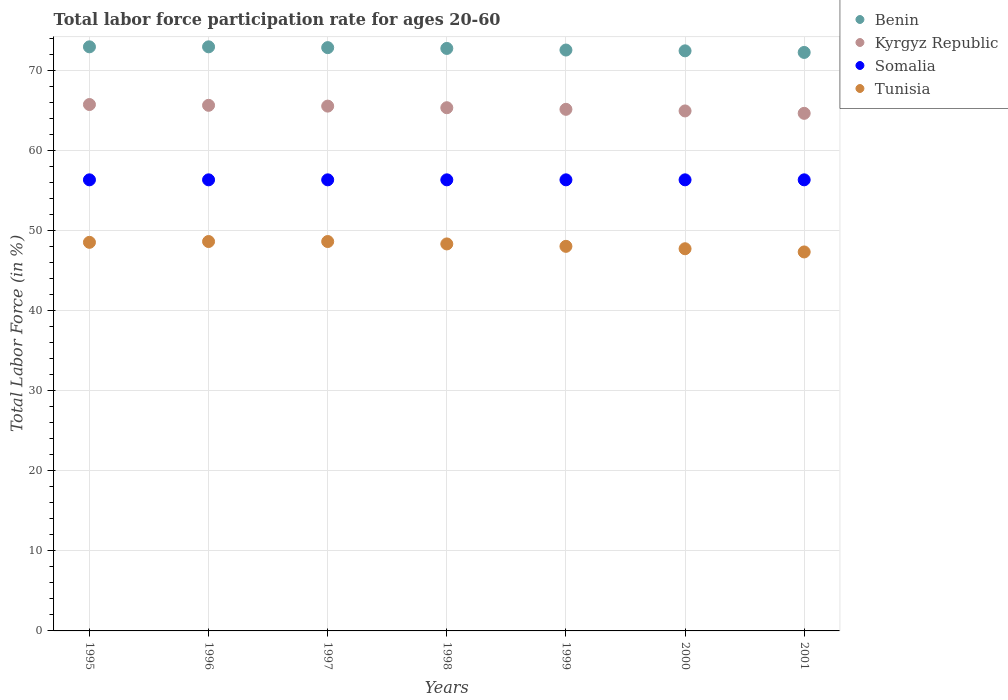What is the labor force participation rate in Somalia in 1996?
Give a very brief answer. 56.3. Across all years, what is the maximum labor force participation rate in Somalia?
Make the answer very short. 56.3. Across all years, what is the minimum labor force participation rate in Kyrgyz Republic?
Give a very brief answer. 64.6. What is the total labor force participation rate in Tunisia in the graph?
Offer a very short reply. 337. What is the difference between the labor force participation rate in Tunisia in 1995 and that in 1996?
Provide a short and direct response. -0.1. What is the difference between the labor force participation rate in Benin in 1997 and the labor force participation rate in Kyrgyz Republic in 2001?
Your answer should be compact. 8.2. What is the average labor force participation rate in Tunisia per year?
Provide a short and direct response. 48.14. In the year 1998, what is the difference between the labor force participation rate in Somalia and labor force participation rate in Kyrgyz Republic?
Provide a short and direct response. -9. What is the ratio of the labor force participation rate in Kyrgyz Republic in 1995 to that in 1996?
Your response must be concise. 1. Is the difference between the labor force participation rate in Somalia in 1996 and 1998 greater than the difference between the labor force participation rate in Kyrgyz Republic in 1996 and 1998?
Your answer should be compact. No. What is the difference between the highest and the lowest labor force participation rate in Benin?
Keep it short and to the point. 0.7. In how many years, is the labor force participation rate in Somalia greater than the average labor force participation rate in Somalia taken over all years?
Provide a short and direct response. 0. Is the labor force participation rate in Somalia strictly greater than the labor force participation rate in Tunisia over the years?
Keep it short and to the point. Yes. How many dotlines are there?
Offer a terse response. 4. How many years are there in the graph?
Ensure brevity in your answer.  7. What is the difference between two consecutive major ticks on the Y-axis?
Give a very brief answer. 10. How many legend labels are there?
Your response must be concise. 4. How are the legend labels stacked?
Your answer should be very brief. Vertical. What is the title of the graph?
Offer a terse response. Total labor force participation rate for ages 20-60. Does "Barbados" appear as one of the legend labels in the graph?
Provide a succinct answer. No. What is the label or title of the Y-axis?
Make the answer very short. Total Labor Force (in %). What is the Total Labor Force (in %) of Benin in 1995?
Offer a very short reply. 72.9. What is the Total Labor Force (in %) of Kyrgyz Republic in 1995?
Make the answer very short. 65.7. What is the Total Labor Force (in %) of Somalia in 1995?
Ensure brevity in your answer.  56.3. What is the Total Labor Force (in %) of Tunisia in 1995?
Your answer should be compact. 48.5. What is the Total Labor Force (in %) in Benin in 1996?
Provide a succinct answer. 72.9. What is the Total Labor Force (in %) of Kyrgyz Republic in 1996?
Your response must be concise. 65.6. What is the Total Labor Force (in %) of Somalia in 1996?
Keep it short and to the point. 56.3. What is the Total Labor Force (in %) of Tunisia in 1996?
Provide a short and direct response. 48.6. What is the Total Labor Force (in %) in Benin in 1997?
Your response must be concise. 72.8. What is the Total Labor Force (in %) of Kyrgyz Republic in 1997?
Give a very brief answer. 65.5. What is the Total Labor Force (in %) of Somalia in 1997?
Ensure brevity in your answer.  56.3. What is the Total Labor Force (in %) in Tunisia in 1997?
Ensure brevity in your answer.  48.6. What is the Total Labor Force (in %) in Benin in 1998?
Your response must be concise. 72.7. What is the Total Labor Force (in %) in Kyrgyz Republic in 1998?
Provide a short and direct response. 65.3. What is the Total Labor Force (in %) of Somalia in 1998?
Offer a terse response. 56.3. What is the Total Labor Force (in %) of Tunisia in 1998?
Make the answer very short. 48.3. What is the Total Labor Force (in %) of Benin in 1999?
Your answer should be compact. 72.5. What is the Total Labor Force (in %) of Kyrgyz Republic in 1999?
Make the answer very short. 65.1. What is the Total Labor Force (in %) of Somalia in 1999?
Your answer should be very brief. 56.3. What is the Total Labor Force (in %) of Benin in 2000?
Your answer should be very brief. 72.4. What is the Total Labor Force (in %) in Kyrgyz Republic in 2000?
Keep it short and to the point. 64.9. What is the Total Labor Force (in %) of Somalia in 2000?
Your response must be concise. 56.3. What is the Total Labor Force (in %) in Tunisia in 2000?
Provide a succinct answer. 47.7. What is the Total Labor Force (in %) of Benin in 2001?
Provide a short and direct response. 72.2. What is the Total Labor Force (in %) of Kyrgyz Republic in 2001?
Give a very brief answer. 64.6. What is the Total Labor Force (in %) of Somalia in 2001?
Provide a short and direct response. 56.3. What is the Total Labor Force (in %) in Tunisia in 2001?
Your response must be concise. 47.3. Across all years, what is the maximum Total Labor Force (in %) in Benin?
Provide a succinct answer. 72.9. Across all years, what is the maximum Total Labor Force (in %) of Kyrgyz Republic?
Give a very brief answer. 65.7. Across all years, what is the maximum Total Labor Force (in %) in Somalia?
Offer a terse response. 56.3. Across all years, what is the maximum Total Labor Force (in %) of Tunisia?
Provide a short and direct response. 48.6. Across all years, what is the minimum Total Labor Force (in %) of Benin?
Your answer should be compact. 72.2. Across all years, what is the minimum Total Labor Force (in %) in Kyrgyz Republic?
Make the answer very short. 64.6. Across all years, what is the minimum Total Labor Force (in %) of Somalia?
Ensure brevity in your answer.  56.3. Across all years, what is the minimum Total Labor Force (in %) of Tunisia?
Give a very brief answer. 47.3. What is the total Total Labor Force (in %) in Benin in the graph?
Make the answer very short. 508.4. What is the total Total Labor Force (in %) of Kyrgyz Republic in the graph?
Give a very brief answer. 456.7. What is the total Total Labor Force (in %) in Somalia in the graph?
Your answer should be compact. 394.1. What is the total Total Labor Force (in %) of Tunisia in the graph?
Ensure brevity in your answer.  337. What is the difference between the Total Labor Force (in %) of Kyrgyz Republic in 1995 and that in 1996?
Offer a very short reply. 0.1. What is the difference between the Total Labor Force (in %) of Tunisia in 1995 and that in 1996?
Your answer should be very brief. -0.1. What is the difference between the Total Labor Force (in %) in Kyrgyz Republic in 1995 and that in 1997?
Provide a succinct answer. 0.2. What is the difference between the Total Labor Force (in %) of Somalia in 1995 and that in 1997?
Your answer should be compact. 0. What is the difference between the Total Labor Force (in %) of Benin in 1995 and that in 1998?
Your response must be concise. 0.2. What is the difference between the Total Labor Force (in %) in Kyrgyz Republic in 1995 and that in 1998?
Provide a short and direct response. 0.4. What is the difference between the Total Labor Force (in %) in Kyrgyz Republic in 1995 and that in 1999?
Ensure brevity in your answer.  0.6. What is the difference between the Total Labor Force (in %) in Tunisia in 1995 and that in 1999?
Your response must be concise. 0.5. What is the difference between the Total Labor Force (in %) in Benin in 1995 and that in 2000?
Offer a terse response. 0.5. What is the difference between the Total Labor Force (in %) of Kyrgyz Republic in 1995 and that in 2000?
Your answer should be compact. 0.8. What is the difference between the Total Labor Force (in %) in Somalia in 1995 and that in 2001?
Provide a short and direct response. 0. What is the difference between the Total Labor Force (in %) in Tunisia in 1995 and that in 2001?
Make the answer very short. 1.2. What is the difference between the Total Labor Force (in %) of Benin in 1996 and that in 1997?
Offer a terse response. 0.1. What is the difference between the Total Labor Force (in %) in Kyrgyz Republic in 1996 and that in 1997?
Provide a short and direct response. 0.1. What is the difference between the Total Labor Force (in %) of Somalia in 1996 and that in 1997?
Offer a very short reply. 0. What is the difference between the Total Labor Force (in %) in Tunisia in 1996 and that in 1997?
Ensure brevity in your answer.  0. What is the difference between the Total Labor Force (in %) in Benin in 1996 and that in 1998?
Provide a short and direct response. 0.2. What is the difference between the Total Labor Force (in %) of Somalia in 1996 and that in 1998?
Keep it short and to the point. 0. What is the difference between the Total Labor Force (in %) in Tunisia in 1996 and that in 1998?
Ensure brevity in your answer.  0.3. What is the difference between the Total Labor Force (in %) of Benin in 1996 and that in 1999?
Your answer should be very brief. 0.4. What is the difference between the Total Labor Force (in %) in Somalia in 1996 and that in 1999?
Ensure brevity in your answer.  0. What is the difference between the Total Labor Force (in %) in Kyrgyz Republic in 1996 and that in 2000?
Keep it short and to the point. 0.7. What is the difference between the Total Labor Force (in %) of Somalia in 1996 and that in 2000?
Make the answer very short. 0. What is the difference between the Total Labor Force (in %) in Tunisia in 1996 and that in 2000?
Provide a short and direct response. 0.9. What is the difference between the Total Labor Force (in %) in Kyrgyz Republic in 1996 and that in 2001?
Give a very brief answer. 1. What is the difference between the Total Labor Force (in %) in Somalia in 1996 and that in 2001?
Your answer should be very brief. 0. What is the difference between the Total Labor Force (in %) of Kyrgyz Republic in 1997 and that in 1998?
Ensure brevity in your answer.  0.2. What is the difference between the Total Labor Force (in %) in Tunisia in 1997 and that in 1998?
Provide a succinct answer. 0.3. What is the difference between the Total Labor Force (in %) in Benin in 1997 and that in 1999?
Ensure brevity in your answer.  0.3. What is the difference between the Total Labor Force (in %) in Kyrgyz Republic in 1997 and that in 1999?
Provide a succinct answer. 0.4. What is the difference between the Total Labor Force (in %) in Somalia in 1997 and that in 1999?
Your answer should be very brief. 0. What is the difference between the Total Labor Force (in %) of Benin in 1997 and that in 2000?
Your response must be concise. 0.4. What is the difference between the Total Labor Force (in %) of Tunisia in 1997 and that in 2000?
Ensure brevity in your answer.  0.9. What is the difference between the Total Labor Force (in %) of Benin in 1997 and that in 2001?
Offer a very short reply. 0.6. What is the difference between the Total Labor Force (in %) of Tunisia in 1997 and that in 2001?
Ensure brevity in your answer.  1.3. What is the difference between the Total Labor Force (in %) in Kyrgyz Republic in 1998 and that in 1999?
Make the answer very short. 0.2. What is the difference between the Total Labor Force (in %) of Somalia in 1998 and that in 1999?
Provide a succinct answer. 0. What is the difference between the Total Labor Force (in %) of Tunisia in 1998 and that in 1999?
Your answer should be compact. 0.3. What is the difference between the Total Labor Force (in %) of Kyrgyz Republic in 1998 and that in 2000?
Provide a short and direct response. 0.4. What is the difference between the Total Labor Force (in %) of Somalia in 1998 and that in 2000?
Your answer should be very brief. 0. What is the difference between the Total Labor Force (in %) of Benin in 1998 and that in 2001?
Your response must be concise. 0.5. What is the difference between the Total Labor Force (in %) in Somalia in 1998 and that in 2001?
Offer a very short reply. 0. What is the difference between the Total Labor Force (in %) in Somalia in 1999 and that in 2000?
Keep it short and to the point. 0. What is the difference between the Total Labor Force (in %) in Benin in 1999 and that in 2001?
Your answer should be very brief. 0.3. What is the difference between the Total Labor Force (in %) in Tunisia in 1999 and that in 2001?
Offer a very short reply. 0.7. What is the difference between the Total Labor Force (in %) in Tunisia in 2000 and that in 2001?
Keep it short and to the point. 0.4. What is the difference between the Total Labor Force (in %) in Benin in 1995 and the Total Labor Force (in %) in Kyrgyz Republic in 1996?
Your response must be concise. 7.3. What is the difference between the Total Labor Force (in %) of Benin in 1995 and the Total Labor Force (in %) of Tunisia in 1996?
Provide a succinct answer. 24.3. What is the difference between the Total Labor Force (in %) in Kyrgyz Republic in 1995 and the Total Labor Force (in %) in Tunisia in 1996?
Provide a succinct answer. 17.1. What is the difference between the Total Labor Force (in %) of Benin in 1995 and the Total Labor Force (in %) of Somalia in 1997?
Your answer should be compact. 16.6. What is the difference between the Total Labor Force (in %) of Benin in 1995 and the Total Labor Force (in %) of Tunisia in 1997?
Provide a short and direct response. 24.3. What is the difference between the Total Labor Force (in %) of Kyrgyz Republic in 1995 and the Total Labor Force (in %) of Somalia in 1997?
Your response must be concise. 9.4. What is the difference between the Total Labor Force (in %) in Kyrgyz Republic in 1995 and the Total Labor Force (in %) in Tunisia in 1997?
Make the answer very short. 17.1. What is the difference between the Total Labor Force (in %) in Somalia in 1995 and the Total Labor Force (in %) in Tunisia in 1997?
Make the answer very short. 7.7. What is the difference between the Total Labor Force (in %) in Benin in 1995 and the Total Labor Force (in %) in Kyrgyz Republic in 1998?
Your response must be concise. 7.6. What is the difference between the Total Labor Force (in %) in Benin in 1995 and the Total Labor Force (in %) in Tunisia in 1998?
Make the answer very short. 24.6. What is the difference between the Total Labor Force (in %) in Kyrgyz Republic in 1995 and the Total Labor Force (in %) in Tunisia in 1998?
Offer a terse response. 17.4. What is the difference between the Total Labor Force (in %) of Somalia in 1995 and the Total Labor Force (in %) of Tunisia in 1998?
Make the answer very short. 8. What is the difference between the Total Labor Force (in %) in Benin in 1995 and the Total Labor Force (in %) in Tunisia in 1999?
Keep it short and to the point. 24.9. What is the difference between the Total Labor Force (in %) of Kyrgyz Republic in 1995 and the Total Labor Force (in %) of Somalia in 1999?
Offer a very short reply. 9.4. What is the difference between the Total Labor Force (in %) of Kyrgyz Republic in 1995 and the Total Labor Force (in %) of Tunisia in 1999?
Your answer should be compact. 17.7. What is the difference between the Total Labor Force (in %) in Somalia in 1995 and the Total Labor Force (in %) in Tunisia in 1999?
Make the answer very short. 8.3. What is the difference between the Total Labor Force (in %) of Benin in 1995 and the Total Labor Force (in %) of Tunisia in 2000?
Provide a short and direct response. 25.2. What is the difference between the Total Labor Force (in %) of Kyrgyz Republic in 1995 and the Total Labor Force (in %) of Somalia in 2000?
Your answer should be very brief. 9.4. What is the difference between the Total Labor Force (in %) of Kyrgyz Republic in 1995 and the Total Labor Force (in %) of Tunisia in 2000?
Provide a succinct answer. 18. What is the difference between the Total Labor Force (in %) of Benin in 1995 and the Total Labor Force (in %) of Tunisia in 2001?
Your answer should be compact. 25.6. What is the difference between the Total Labor Force (in %) in Kyrgyz Republic in 1995 and the Total Labor Force (in %) in Somalia in 2001?
Give a very brief answer. 9.4. What is the difference between the Total Labor Force (in %) of Kyrgyz Republic in 1995 and the Total Labor Force (in %) of Tunisia in 2001?
Offer a terse response. 18.4. What is the difference between the Total Labor Force (in %) in Benin in 1996 and the Total Labor Force (in %) in Tunisia in 1997?
Keep it short and to the point. 24.3. What is the difference between the Total Labor Force (in %) of Kyrgyz Republic in 1996 and the Total Labor Force (in %) of Tunisia in 1997?
Offer a terse response. 17. What is the difference between the Total Labor Force (in %) in Somalia in 1996 and the Total Labor Force (in %) in Tunisia in 1997?
Offer a terse response. 7.7. What is the difference between the Total Labor Force (in %) in Benin in 1996 and the Total Labor Force (in %) in Kyrgyz Republic in 1998?
Make the answer very short. 7.6. What is the difference between the Total Labor Force (in %) in Benin in 1996 and the Total Labor Force (in %) in Somalia in 1998?
Offer a terse response. 16.6. What is the difference between the Total Labor Force (in %) of Benin in 1996 and the Total Labor Force (in %) of Tunisia in 1998?
Give a very brief answer. 24.6. What is the difference between the Total Labor Force (in %) of Kyrgyz Republic in 1996 and the Total Labor Force (in %) of Somalia in 1998?
Provide a short and direct response. 9.3. What is the difference between the Total Labor Force (in %) of Kyrgyz Republic in 1996 and the Total Labor Force (in %) of Tunisia in 1998?
Your answer should be very brief. 17.3. What is the difference between the Total Labor Force (in %) of Benin in 1996 and the Total Labor Force (in %) of Kyrgyz Republic in 1999?
Offer a very short reply. 7.8. What is the difference between the Total Labor Force (in %) of Benin in 1996 and the Total Labor Force (in %) of Somalia in 1999?
Offer a terse response. 16.6. What is the difference between the Total Labor Force (in %) of Benin in 1996 and the Total Labor Force (in %) of Tunisia in 1999?
Provide a succinct answer. 24.9. What is the difference between the Total Labor Force (in %) in Benin in 1996 and the Total Labor Force (in %) in Somalia in 2000?
Make the answer very short. 16.6. What is the difference between the Total Labor Force (in %) of Benin in 1996 and the Total Labor Force (in %) of Tunisia in 2000?
Provide a succinct answer. 25.2. What is the difference between the Total Labor Force (in %) in Kyrgyz Republic in 1996 and the Total Labor Force (in %) in Somalia in 2000?
Make the answer very short. 9.3. What is the difference between the Total Labor Force (in %) of Kyrgyz Republic in 1996 and the Total Labor Force (in %) of Tunisia in 2000?
Provide a short and direct response. 17.9. What is the difference between the Total Labor Force (in %) in Somalia in 1996 and the Total Labor Force (in %) in Tunisia in 2000?
Offer a terse response. 8.6. What is the difference between the Total Labor Force (in %) in Benin in 1996 and the Total Labor Force (in %) in Somalia in 2001?
Keep it short and to the point. 16.6. What is the difference between the Total Labor Force (in %) in Benin in 1996 and the Total Labor Force (in %) in Tunisia in 2001?
Offer a very short reply. 25.6. What is the difference between the Total Labor Force (in %) of Kyrgyz Republic in 1996 and the Total Labor Force (in %) of Somalia in 2001?
Your answer should be compact. 9.3. What is the difference between the Total Labor Force (in %) of Kyrgyz Republic in 1996 and the Total Labor Force (in %) of Tunisia in 2001?
Offer a very short reply. 18.3. What is the difference between the Total Labor Force (in %) of Somalia in 1996 and the Total Labor Force (in %) of Tunisia in 2001?
Ensure brevity in your answer.  9. What is the difference between the Total Labor Force (in %) in Benin in 1997 and the Total Labor Force (in %) in Kyrgyz Republic in 1998?
Keep it short and to the point. 7.5. What is the difference between the Total Labor Force (in %) in Benin in 1997 and the Total Labor Force (in %) in Tunisia in 1998?
Give a very brief answer. 24.5. What is the difference between the Total Labor Force (in %) in Kyrgyz Republic in 1997 and the Total Labor Force (in %) in Somalia in 1998?
Offer a terse response. 9.2. What is the difference between the Total Labor Force (in %) of Kyrgyz Republic in 1997 and the Total Labor Force (in %) of Tunisia in 1998?
Keep it short and to the point. 17.2. What is the difference between the Total Labor Force (in %) in Benin in 1997 and the Total Labor Force (in %) in Kyrgyz Republic in 1999?
Make the answer very short. 7.7. What is the difference between the Total Labor Force (in %) in Benin in 1997 and the Total Labor Force (in %) in Somalia in 1999?
Keep it short and to the point. 16.5. What is the difference between the Total Labor Force (in %) in Benin in 1997 and the Total Labor Force (in %) in Tunisia in 1999?
Provide a succinct answer. 24.8. What is the difference between the Total Labor Force (in %) of Kyrgyz Republic in 1997 and the Total Labor Force (in %) of Tunisia in 1999?
Provide a succinct answer. 17.5. What is the difference between the Total Labor Force (in %) of Benin in 1997 and the Total Labor Force (in %) of Somalia in 2000?
Your answer should be compact. 16.5. What is the difference between the Total Labor Force (in %) in Benin in 1997 and the Total Labor Force (in %) in Tunisia in 2000?
Ensure brevity in your answer.  25.1. What is the difference between the Total Labor Force (in %) in Kyrgyz Republic in 1997 and the Total Labor Force (in %) in Somalia in 2000?
Provide a succinct answer. 9.2. What is the difference between the Total Labor Force (in %) in Benin in 1997 and the Total Labor Force (in %) in Kyrgyz Republic in 2001?
Your answer should be very brief. 8.2. What is the difference between the Total Labor Force (in %) of Benin in 1997 and the Total Labor Force (in %) of Somalia in 2001?
Ensure brevity in your answer.  16.5. What is the difference between the Total Labor Force (in %) in Kyrgyz Republic in 1997 and the Total Labor Force (in %) in Somalia in 2001?
Provide a short and direct response. 9.2. What is the difference between the Total Labor Force (in %) in Kyrgyz Republic in 1997 and the Total Labor Force (in %) in Tunisia in 2001?
Keep it short and to the point. 18.2. What is the difference between the Total Labor Force (in %) in Somalia in 1997 and the Total Labor Force (in %) in Tunisia in 2001?
Your response must be concise. 9. What is the difference between the Total Labor Force (in %) of Benin in 1998 and the Total Labor Force (in %) of Tunisia in 1999?
Your answer should be very brief. 24.7. What is the difference between the Total Labor Force (in %) of Kyrgyz Republic in 1998 and the Total Labor Force (in %) of Somalia in 1999?
Provide a short and direct response. 9. What is the difference between the Total Labor Force (in %) of Kyrgyz Republic in 1998 and the Total Labor Force (in %) of Tunisia in 1999?
Offer a terse response. 17.3. What is the difference between the Total Labor Force (in %) in Somalia in 1998 and the Total Labor Force (in %) in Tunisia in 1999?
Your answer should be compact. 8.3. What is the difference between the Total Labor Force (in %) of Somalia in 1998 and the Total Labor Force (in %) of Tunisia in 2000?
Make the answer very short. 8.6. What is the difference between the Total Labor Force (in %) in Benin in 1998 and the Total Labor Force (in %) in Somalia in 2001?
Your answer should be very brief. 16.4. What is the difference between the Total Labor Force (in %) in Benin in 1998 and the Total Labor Force (in %) in Tunisia in 2001?
Provide a short and direct response. 25.4. What is the difference between the Total Labor Force (in %) of Kyrgyz Republic in 1998 and the Total Labor Force (in %) of Somalia in 2001?
Offer a terse response. 9. What is the difference between the Total Labor Force (in %) of Somalia in 1998 and the Total Labor Force (in %) of Tunisia in 2001?
Your answer should be very brief. 9. What is the difference between the Total Labor Force (in %) of Benin in 1999 and the Total Labor Force (in %) of Kyrgyz Republic in 2000?
Keep it short and to the point. 7.6. What is the difference between the Total Labor Force (in %) of Benin in 1999 and the Total Labor Force (in %) of Tunisia in 2000?
Provide a succinct answer. 24.8. What is the difference between the Total Labor Force (in %) of Somalia in 1999 and the Total Labor Force (in %) of Tunisia in 2000?
Offer a terse response. 8.6. What is the difference between the Total Labor Force (in %) of Benin in 1999 and the Total Labor Force (in %) of Somalia in 2001?
Ensure brevity in your answer.  16.2. What is the difference between the Total Labor Force (in %) in Benin in 1999 and the Total Labor Force (in %) in Tunisia in 2001?
Keep it short and to the point. 25.2. What is the difference between the Total Labor Force (in %) in Kyrgyz Republic in 1999 and the Total Labor Force (in %) in Tunisia in 2001?
Your answer should be compact. 17.8. What is the difference between the Total Labor Force (in %) of Somalia in 1999 and the Total Labor Force (in %) of Tunisia in 2001?
Make the answer very short. 9. What is the difference between the Total Labor Force (in %) in Benin in 2000 and the Total Labor Force (in %) in Somalia in 2001?
Offer a terse response. 16.1. What is the difference between the Total Labor Force (in %) in Benin in 2000 and the Total Labor Force (in %) in Tunisia in 2001?
Ensure brevity in your answer.  25.1. What is the difference between the Total Labor Force (in %) of Kyrgyz Republic in 2000 and the Total Labor Force (in %) of Somalia in 2001?
Provide a succinct answer. 8.6. What is the difference between the Total Labor Force (in %) in Kyrgyz Republic in 2000 and the Total Labor Force (in %) in Tunisia in 2001?
Keep it short and to the point. 17.6. What is the difference between the Total Labor Force (in %) in Somalia in 2000 and the Total Labor Force (in %) in Tunisia in 2001?
Offer a terse response. 9. What is the average Total Labor Force (in %) in Benin per year?
Ensure brevity in your answer.  72.63. What is the average Total Labor Force (in %) of Kyrgyz Republic per year?
Provide a succinct answer. 65.24. What is the average Total Labor Force (in %) of Somalia per year?
Your response must be concise. 56.3. What is the average Total Labor Force (in %) in Tunisia per year?
Your answer should be compact. 48.14. In the year 1995, what is the difference between the Total Labor Force (in %) of Benin and Total Labor Force (in %) of Kyrgyz Republic?
Make the answer very short. 7.2. In the year 1995, what is the difference between the Total Labor Force (in %) in Benin and Total Labor Force (in %) in Somalia?
Your answer should be very brief. 16.6. In the year 1995, what is the difference between the Total Labor Force (in %) in Benin and Total Labor Force (in %) in Tunisia?
Your answer should be compact. 24.4. In the year 1995, what is the difference between the Total Labor Force (in %) of Kyrgyz Republic and Total Labor Force (in %) of Tunisia?
Your answer should be very brief. 17.2. In the year 1995, what is the difference between the Total Labor Force (in %) in Somalia and Total Labor Force (in %) in Tunisia?
Provide a succinct answer. 7.8. In the year 1996, what is the difference between the Total Labor Force (in %) in Benin and Total Labor Force (in %) in Somalia?
Your response must be concise. 16.6. In the year 1996, what is the difference between the Total Labor Force (in %) of Benin and Total Labor Force (in %) of Tunisia?
Provide a short and direct response. 24.3. In the year 1997, what is the difference between the Total Labor Force (in %) of Benin and Total Labor Force (in %) of Tunisia?
Make the answer very short. 24.2. In the year 1997, what is the difference between the Total Labor Force (in %) in Kyrgyz Republic and Total Labor Force (in %) in Somalia?
Provide a short and direct response. 9.2. In the year 1997, what is the difference between the Total Labor Force (in %) of Somalia and Total Labor Force (in %) of Tunisia?
Provide a short and direct response. 7.7. In the year 1998, what is the difference between the Total Labor Force (in %) of Benin and Total Labor Force (in %) of Tunisia?
Provide a short and direct response. 24.4. In the year 1998, what is the difference between the Total Labor Force (in %) in Kyrgyz Republic and Total Labor Force (in %) in Somalia?
Keep it short and to the point. 9. In the year 1998, what is the difference between the Total Labor Force (in %) of Kyrgyz Republic and Total Labor Force (in %) of Tunisia?
Your answer should be compact. 17. In the year 2000, what is the difference between the Total Labor Force (in %) of Benin and Total Labor Force (in %) of Kyrgyz Republic?
Keep it short and to the point. 7.5. In the year 2000, what is the difference between the Total Labor Force (in %) in Benin and Total Labor Force (in %) in Somalia?
Offer a terse response. 16.1. In the year 2000, what is the difference between the Total Labor Force (in %) of Benin and Total Labor Force (in %) of Tunisia?
Your answer should be compact. 24.7. In the year 2000, what is the difference between the Total Labor Force (in %) of Kyrgyz Republic and Total Labor Force (in %) of Somalia?
Make the answer very short. 8.6. In the year 2000, what is the difference between the Total Labor Force (in %) of Kyrgyz Republic and Total Labor Force (in %) of Tunisia?
Your answer should be very brief. 17.2. In the year 2000, what is the difference between the Total Labor Force (in %) of Somalia and Total Labor Force (in %) of Tunisia?
Provide a short and direct response. 8.6. In the year 2001, what is the difference between the Total Labor Force (in %) of Benin and Total Labor Force (in %) of Kyrgyz Republic?
Your response must be concise. 7.6. In the year 2001, what is the difference between the Total Labor Force (in %) in Benin and Total Labor Force (in %) in Tunisia?
Ensure brevity in your answer.  24.9. In the year 2001, what is the difference between the Total Labor Force (in %) of Kyrgyz Republic and Total Labor Force (in %) of Somalia?
Provide a succinct answer. 8.3. In the year 2001, what is the difference between the Total Labor Force (in %) of Kyrgyz Republic and Total Labor Force (in %) of Tunisia?
Keep it short and to the point. 17.3. In the year 2001, what is the difference between the Total Labor Force (in %) of Somalia and Total Labor Force (in %) of Tunisia?
Your answer should be very brief. 9. What is the ratio of the Total Labor Force (in %) of Kyrgyz Republic in 1995 to that in 1996?
Provide a short and direct response. 1. What is the ratio of the Total Labor Force (in %) in Somalia in 1995 to that in 1996?
Provide a succinct answer. 1. What is the ratio of the Total Labor Force (in %) of Kyrgyz Republic in 1995 to that in 1997?
Give a very brief answer. 1. What is the ratio of the Total Labor Force (in %) in Somalia in 1995 to that in 1997?
Offer a very short reply. 1. What is the ratio of the Total Labor Force (in %) in Kyrgyz Republic in 1995 to that in 1998?
Offer a terse response. 1.01. What is the ratio of the Total Labor Force (in %) of Somalia in 1995 to that in 1998?
Your answer should be compact. 1. What is the ratio of the Total Labor Force (in %) of Benin in 1995 to that in 1999?
Make the answer very short. 1.01. What is the ratio of the Total Labor Force (in %) in Kyrgyz Republic in 1995 to that in 1999?
Provide a short and direct response. 1.01. What is the ratio of the Total Labor Force (in %) of Somalia in 1995 to that in 1999?
Keep it short and to the point. 1. What is the ratio of the Total Labor Force (in %) in Tunisia in 1995 to that in 1999?
Give a very brief answer. 1.01. What is the ratio of the Total Labor Force (in %) of Kyrgyz Republic in 1995 to that in 2000?
Keep it short and to the point. 1.01. What is the ratio of the Total Labor Force (in %) of Tunisia in 1995 to that in 2000?
Keep it short and to the point. 1.02. What is the ratio of the Total Labor Force (in %) of Benin in 1995 to that in 2001?
Keep it short and to the point. 1.01. What is the ratio of the Total Labor Force (in %) in Tunisia in 1995 to that in 2001?
Offer a terse response. 1.03. What is the ratio of the Total Labor Force (in %) of Benin in 1996 to that in 1997?
Provide a succinct answer. 1. What is the ratio of the Total Labor Force (in %) in Tunisia in 1996 to that in 1997?
Provide a short and direct response. 1. What is the ratio of the Total Labor Force (in %) in Benin in 1996 to that in 1998?
Keep it short and to the point. 1. What is the ratio of the Total Labor Force (in %) in Kyrgyz Republic in 1996 to that in 1998?
Provide a succinct answer. 1. What is the ratio of the Total Labor Force (in %) in Somalia in 1996 to that in 1998?
Offer a terse response. 1. What is the ratio of the Total Labor Force (in %) of Tunisia in 1996 to that in 1998?
Offer a terse response. 1.01. What is the ratio of the Total Labor Force (in %) in Benin in 1996 to that in 1999?
Offer a very short reply. 1.01. What is the ratio of the Total Labor Force (in %) in Kyrgyz Republic in 1996 to that in 1999?
Your response must be concise. 1.01. What is the ratio of the Total Labor Force (in %) in Tunisia in 1996 to that in 1999?
Give a very brief answer. 1.01. What is the ratio of the Total Labor Force (in %) of Kyrgyz Republic in 1996 to that in 2000?
Offer a very short reply. 1.01. What is the ratio of the Total Labor Force (in %) of Tunisia in 1996 to that in 2000?
Your answer should be very brief. 1.02. What is the ratio of the Total Labor Force (in %) in Benin in 1996 to that in 2001?
Your answer should be compact. 1.01. What is the ratio of the Total Labor Force (in %) in Kyrgyz Republic in 1996 to that in 2001?
Keep it short and to the point. 1.02. What is the ratio of the Total Labor Force (in %) in Tunisia in 1996 to that in 2001?
Make the answer very short. 1.03. What is the ratio of the Total Labor Force (in %) of Benin in 1997 to that in 1998?
Give a very brief answer. 1. What is the ratio of the Total Labor Force (in %) of Tunisia in 1997 to that in 1999?
Ensure brevity in your answer.  1.01. What is the ratio of the Total Labor Force (in %) in Kyrgyz Republic in 1997 to that in 2000?
Make the answer very short. 1.01. What is the ratio of the Total Labor Force (in %) of Tunisia in 1997 to that in 2000?
Your response must be concise. 1.02. What is the ratio of the Total Labor Force (in %) of Benin in 1997 to that in 2001?
Make the answer very short. 1.01. What is the ratio of the Total Labor Force (in %) in Kyrgyz Republic in 1997 to that in 2001?
Offer a very short reply. 1.01. What is the ratio of the Total Labor Force (in %) in Somalia in 1997 to that in 2001?
Your response must be concise. 1. What is the ratio of the Total Labor Force (in %) in Tunisia in 1997 to that in 2001?
Provide a short and direct response. 1.03. What is the ratio of the Total Labor Force (in %) in Benin in 1998 to that in 1999?
Offer a terse response. 1. What is the ratio of the Total Labor Force (in %) in Somalia in 1998 to that in 1999?
Offer a terse response. 1. What is the ratio of the Total Labor Force (in %) of Tunisia in 1998 to that in 1999?
Offer a very short reply. 1.01. What is the ratio of the Total Labor Force (in %) in Benin in 1998 to that in 2000?
Provide a short and direct response. 1. What is the ratio of the Total Labor Force (in %) of Kyrgyz Republic in 1998 to that in 2000?
Provide a succinct answer. 1.01. What is the ratio of the Total Labor Force (in %) of Somalia in 1998 to that in 2000?
Your response must be concise. 1. What is the ratio of the Total Labor Force (in %) of Tunisia in 1998 to that in 2000?
Your response must be concise. 1.01. What is the ratio of the Total Labor Force (in %) of Kyrgyz Republic in 1998 to that in 2001?
Provide a short and direct response. 1.01. What is the ratio of the Total Labor Force (in %) in Somalia in 1998 to that in 2001?
Provide a succinct answer. 1. What is the ratio of the Total Labor Force (in %) in Tunisia in 1998 to that in 2001?
Provide a short and direct response. 1.02. What is the ratio of the Total Labor Force (in %) of Benin in 1999 to that in 2000?
Provide a succinct answer. 1. What is the ratio of the Total Labor Force (in %) of Kyrgyz Republic in 1999 to that in 2000?
Your answer should be very brief. 1. What is the ratio of the Total Labor Force (in %) in Kyrgyz Republic in 1999 to that in 2001?
Keep it short and to the point. 1.01. What is the ratio of the Total Labor Force (in %) in Tunisia in 1999 to that in 2001?
Offer a very short reply. 1.01. What is the ratio of the Total Labor Force (in %) of Tunisia in 2000 to that in 2001?
Provide a succinct answer. 1.01. What is the difference between the highest and the second highest Total Labor Force (in %) in Kyrgyz Republic?
Offer a very short reply. 0.1. What is the difference between the highest and the second highest Total Labor Force (in %) of Somalia?
Your answer should be very brief. 0. What is the difference between the highest and the second highest Total Labor Force (in %) of Tunisia?
Your answer should be compact. 0. What is the difference between the highest and the lowest Total Labor Force (in %) in Kyrgyz Republic?
Provide a succinct answer. 1.1. What is the difference between the highest and the lowest Total Labor Force (in %) in Somalia?
Provide a short and direct response. 0. 